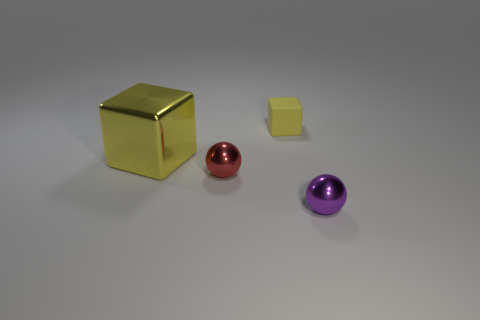Add 3 small purple matte spheres. How many objects exist? 7 Add 1 yellow matte things. How many yellow matte things exist? 2 Subtract 0 brown cylinders. How many objects are left? 4 Subtract all red metallic spheres. Subtract all rubber spheres. How many objects are left? 3 Add 2 tiny blocks. How many tiny blocks are left? 3 